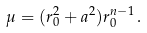Convert formula to latex. <formula><loc_0><loc_0><loc_500><loc_500>\mu = ( r _ { 0 } ^ { 2 } + a ^ { 2 } ) r _ { 0 } ^ { n - 1 } \, .</formula> 